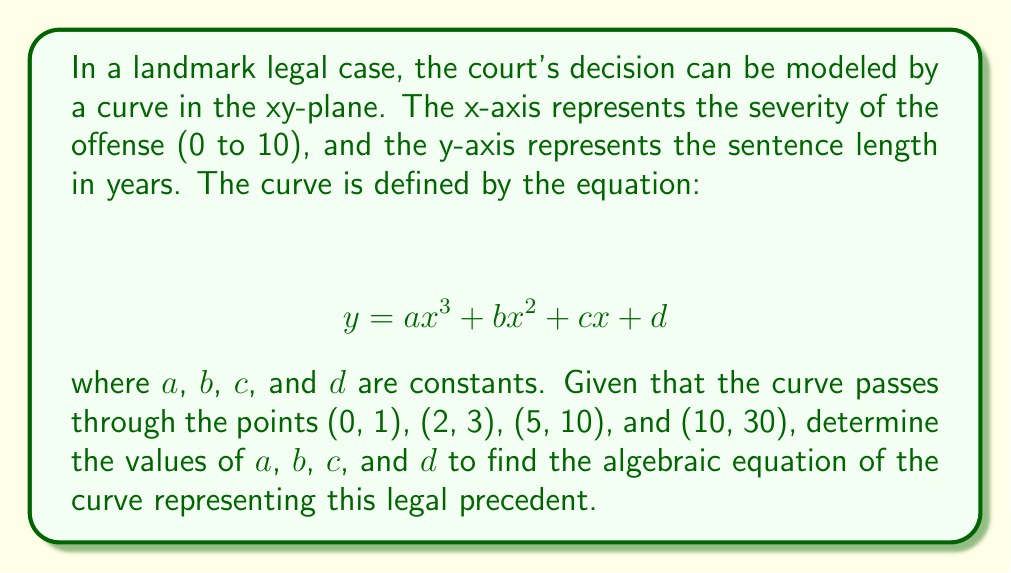Could you help me with this problem? To solve this problem, we'll use the given points to create a system of equations and then solve for the unknowns $a$, $b$, $c$, and $d$.

Step 1: Set up the system of equations using the given points:
1) For (0, 1): $1 = a(0)^3 + b(0)^2 + c(0) + d$ simplifies to $1 = d$
2) For (2, 3): $3 = a(2)^3 + b(2)^2 + c(2) + d = 8a + 4b + 2c + d$
3) For (5, 10): $10 = a(5)^3 + b(5)^2 + c(5) + d = 125a + 25b + 5c + d$
4) For (10, 30): $30 = a(10)^3 + b(10)^2 + c(10) + d = 1000a + 100b + 10c + d$

Step 2: Simplify the system of equations:
1) $d = 1$
2) $8a + 4b + 2c = 2$
3) $125a + 25b + 5c = 9$
4) $1000a + 100b + 10c = 29$

Step 3: Subtract equation 1 from equations 2, 3, and 4:
2) $8a + 4b + 2c = 2$
3) $125a + 25b + 5c = 9$
4) $1000a + 100b + 10c = 29$

Step 4: Use Gaussian elimination to solve the system:
Multiply equation 2 by -15.625 and add to equation 3:
$-1b - 0.625c = -22.25$

Multiply equation 2 by -125 and add to equation 4:
$4b + 2c = -221$

Step 5: Solve for $b$ and $c$ using the equations from Step 4:
$b = 0.1$
$c = -110.6$

Step 6: Substitute these values back into equation 2 to solve for $a$:
$8a + 4(0.1) + 2(-110.6) = 2$
$8a = 223.6$
$a = 27.95$

Step 7: Recall that $d = 1$ from Step 2.

Therefore, the values are:
$a = 27.95$
$b = 0.1$
$c = -110.6$
$d = 1$
Answer: $y = 27.95x^3 + 0.1x^2 - 110.6x + 1$ 